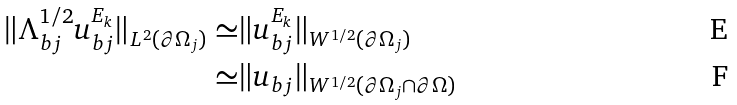<formula> <loc_0><loc_0><loc_500><loc_500>\| \Lambda _ { b j } ^ { 1 / 2 } u _ { b j } ^ { E _ { k } } \| _ { L ^ { 2 } ( \partial \Omega _ { j } ) } \simeq & \| u _ { b j } ^ { E _ { k } } \| _ { W ^ { 1 / 2 } ( \partial \Omega _ { j } ) } \\ \simeq & \| u _ { b j } \| _ { W ^ { 1 / 2 } ( \partial \Omega _ { j } \cap \partial \Omega ) }</formula> 